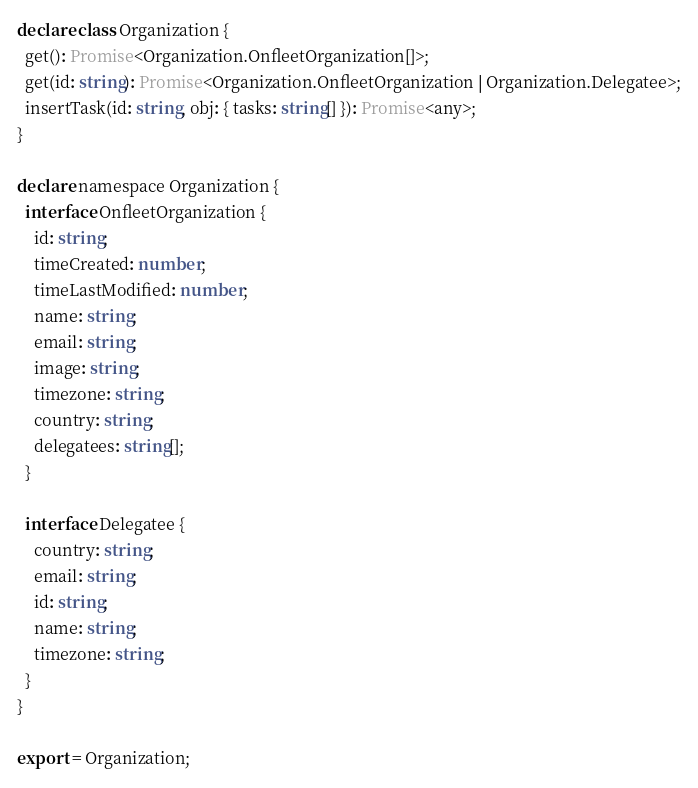<code> <loc_0><loc_0><loc_500><loc_500><_TypeScript_>declare class Organization {
  get(): Promise<Organization.OnfleetOrganization[]>;
  get(id: string): Promise<Organization.OnfleetOrganization | Organization.Delegatee>;
  insertTask(id: string, obj: { tasks: string[] }): Promise<any>;
}

declare namespace Organization {
  interface OnfleetOrganization {
    id: string;
    timeCreated: number;
    timeLastModified: number;
    name: string;
    email: string;
    image: string;
    timezone: string;
    country: string;
    delegatees: string[];
  }

  interface Delegatee {
    country: string;
    email: string;
    id: string;
    name: string;
    timezone: string;
  }
}

export = Organization;
</code> 